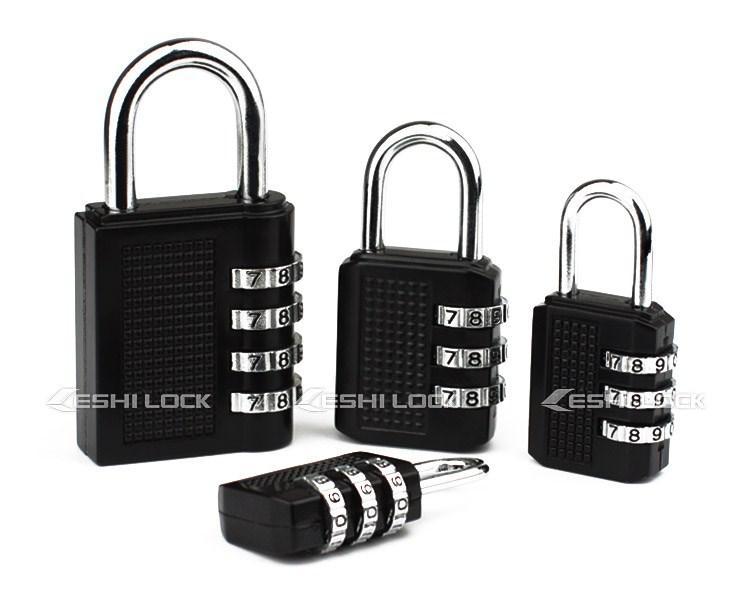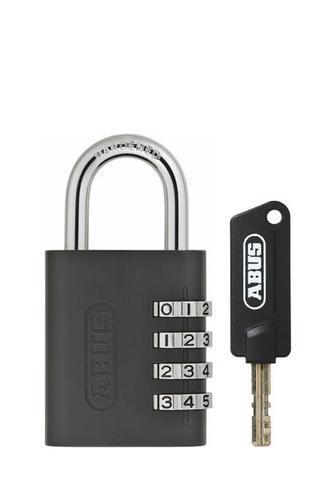The first image is the image on the left, the second image is the image on the right. For the images shown, is this caption "In one image in each pair a lock is unlocked and open." true? Answer yes or no. No. The first image is the image on the left, the second image is the image on the right. Analyze the images presented: Is the assertion "We have two combination locks." valid? Answer yes or no. No. 